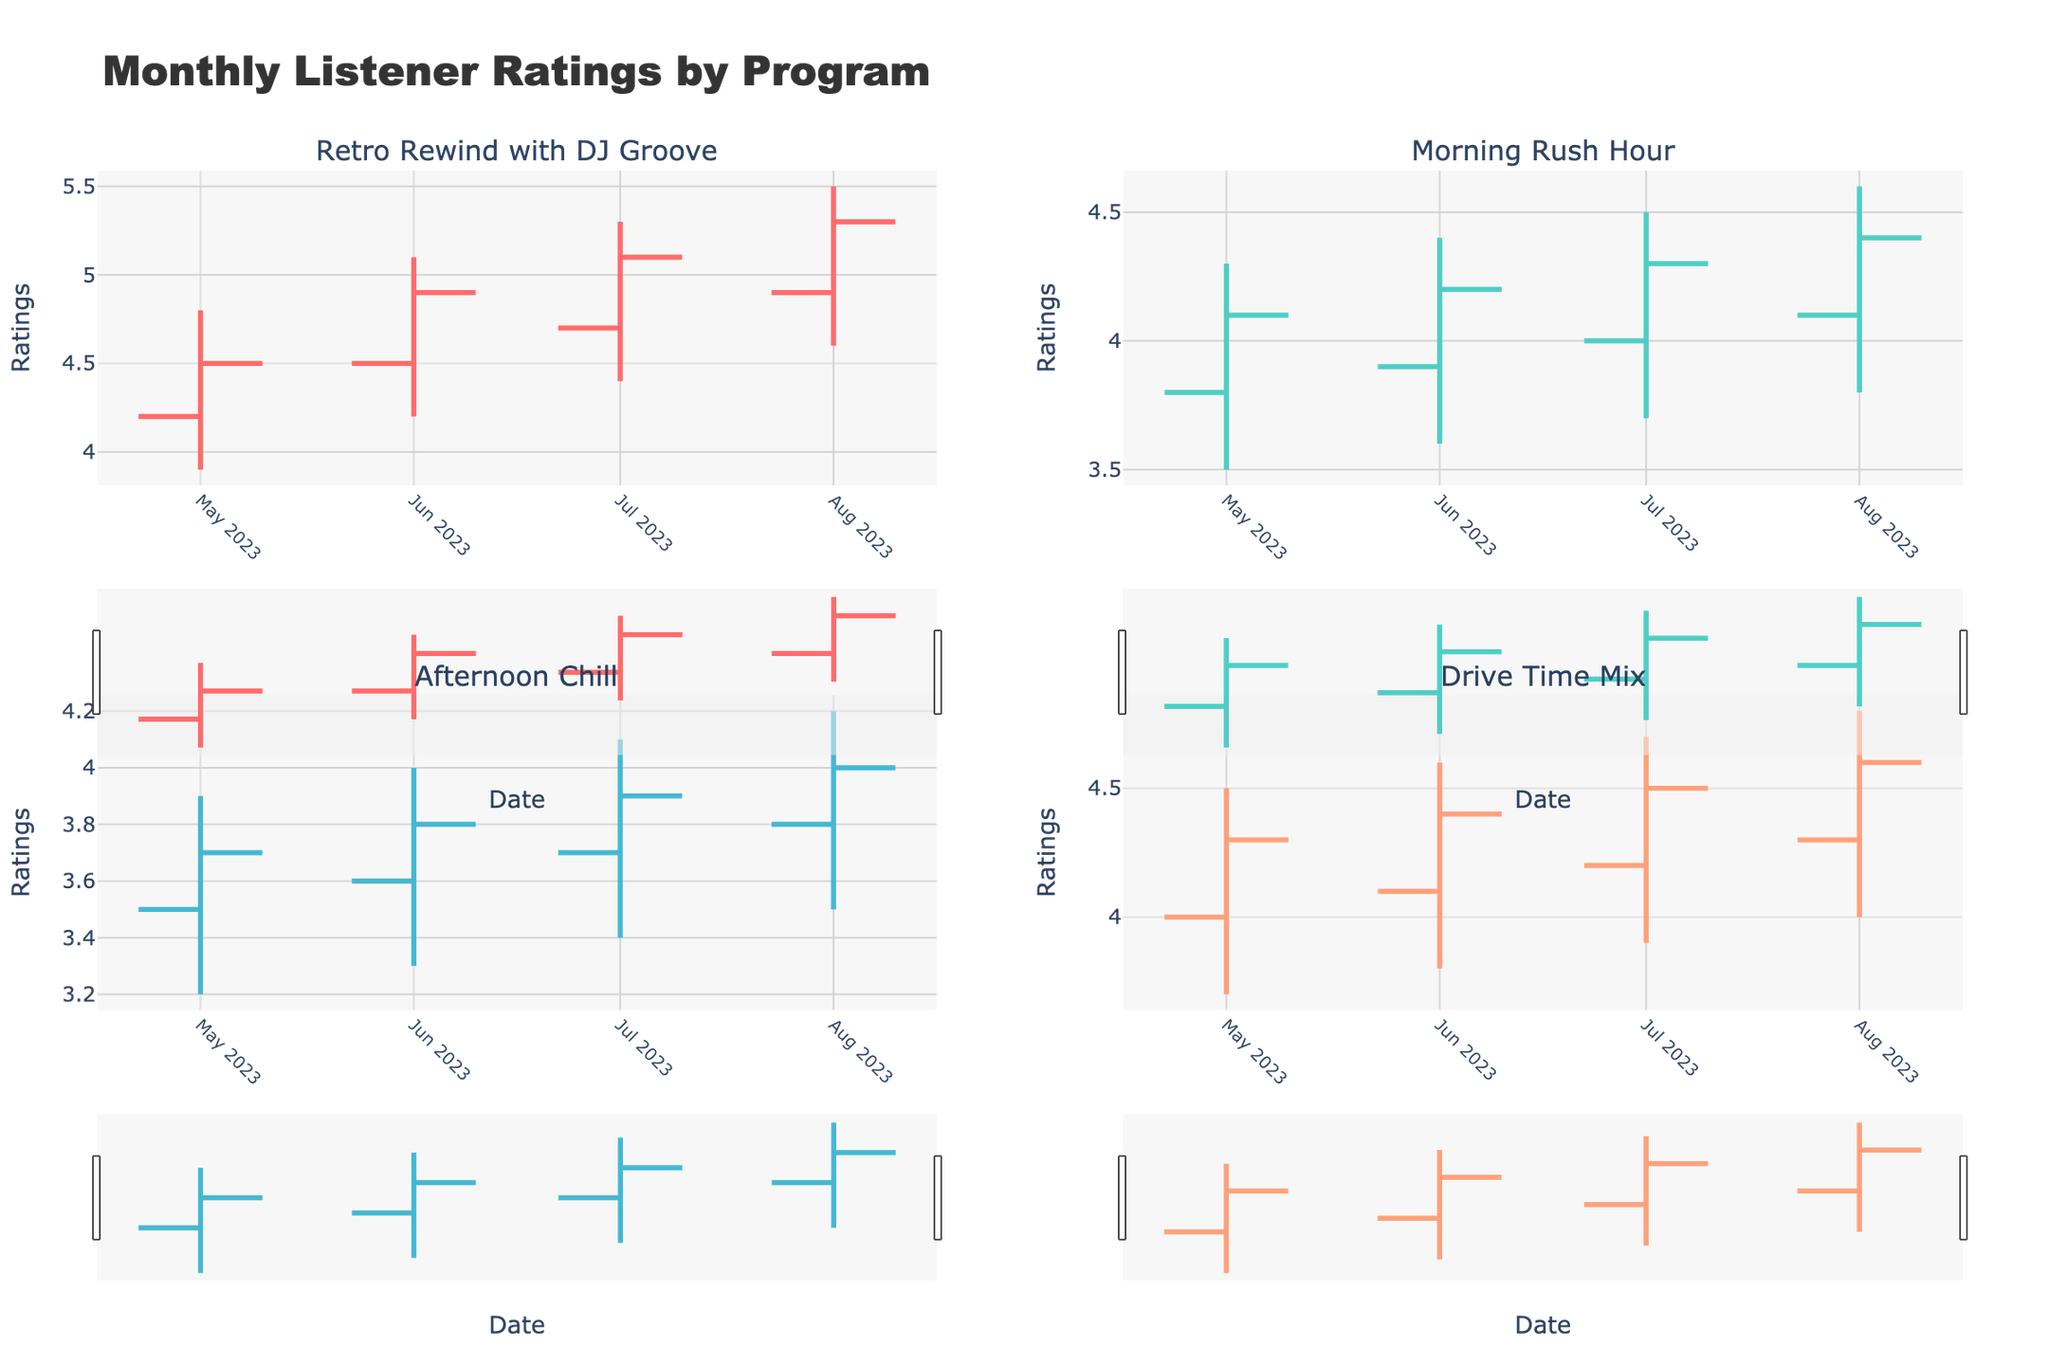What's the title of the figure? The title is prominently displayed at the top of the figure. Look for the largest text which usually contains overall summary information of the data being presented.
Answer: Monthly Listener Ratings by Program What does the x-axis represent in each subplot? The x-axis typically represents the time/date component in an OHLC chart for monthly listener ratings, so look for date labels along this axis in each subplot.
Answer: Date Which program had the highest closing rating in August 2023? In the Retro Rewind with DJ Groove subplot for August 2023, the close value is 5.3, which is the highest closing rating seen in any subplot for that month.
Answer: Retro Rewind with DJ Groove What pattern can be observed in the ratings of Retro Rewind with DJ Groove over the months? Analyzing the OHLC data for Retro Rewind with DJ Groove, the closing values increase from May to August, indicating a consistent rise in monthly listener ratings.
Answer: Increasing trend Compare the opening ratings between Morning Rush Hour and Drive Time Mix for July 2023. Which one is higher? Locate the July 2023 data points for both programs and compare the opening values. Morning Rush Hour starts at 4.0, while Drive Time Mix starts at 4.2.
Answer: Drive Time Mix Looking at the 'Afternoon Chill' program, what is the difference between the lowest rating in June 2023 and the highest rating in July 2023? Subtract the lowest rating in June (3.3) from the highest rating in July (4.1): 4.1 - 3.3 = 0.8.
Answer: 0.8 What's the overall trend in the closing ratings of Morning Rush Hour from May to August 2023? Observing the closing values: May 4.1, June 4.2, July 4.3, and August 4.4, there is a steady month-over-month increase.
Answer: Increasing trend Which program had the smallest range (difference between high and low ratings) in June 2023? Examine the high-low spans for each program in June. The smallest difference is observed in 'Morning Rush Hour' (4.4 - 3.6 = 0.8).
Answer: Morning Rush Hour What was the highest high rating recorded across all programs in August 2023? Identify the highest peak in August charts. Retro Rewind with DJ Groove has a high of 5.5, which is the maximum value seen.
Answer: 5.5 